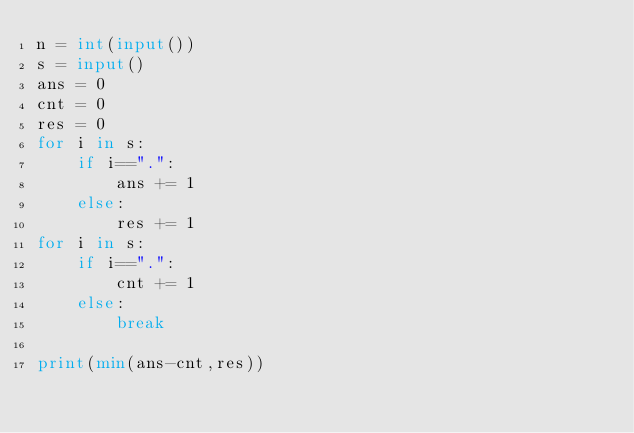<code> <loc_0><loc_0><loc_500><loc_500><_Python_>n = int(input())
s = input()
ans = 0
cnt = 0
res = 0
for i in s:
    if i==".":
        ans += 1
    else:
        res += 1
for i in s:
    if i==".":
        cnt += 1
    else:
        break

print(min(ans-cnt,res))</code> 